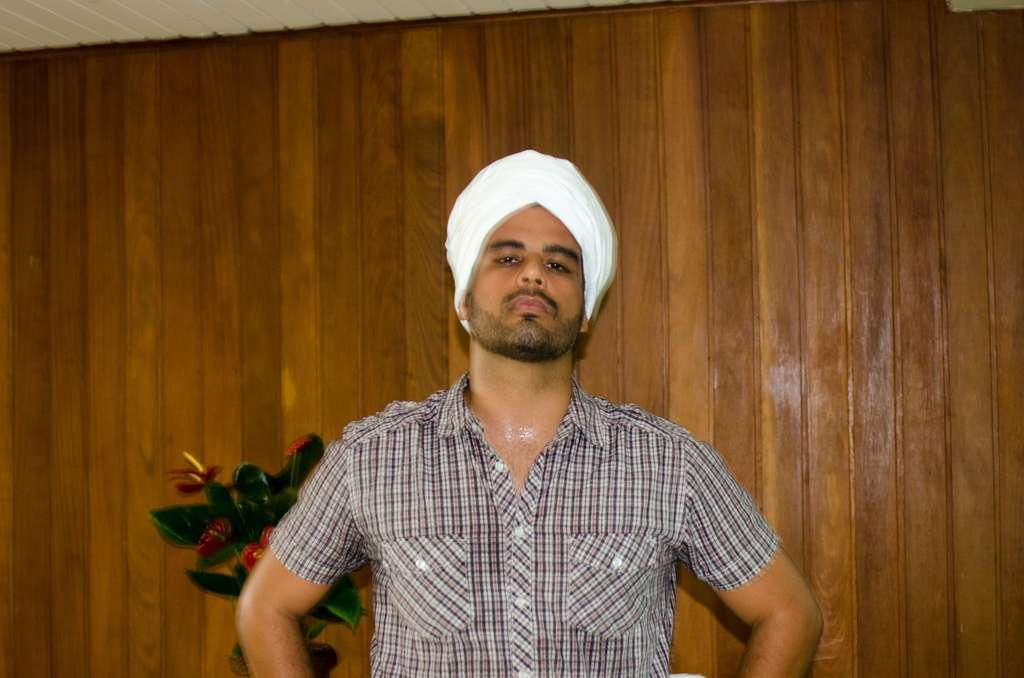What is the appearance of the man in the image? There is a man with a turban in the image. What object can be seen beside the man? There is a flower vase in the image. What type of wall is visible in the background of the image? There is a wooden wall in the background of the image. What type of mint is growing on the wooden wall in the image? There is no mint growing on the wooden wall in the image. What button is the man wearing on his turban in the image? The man in the image is not wearing a button on his turban. 